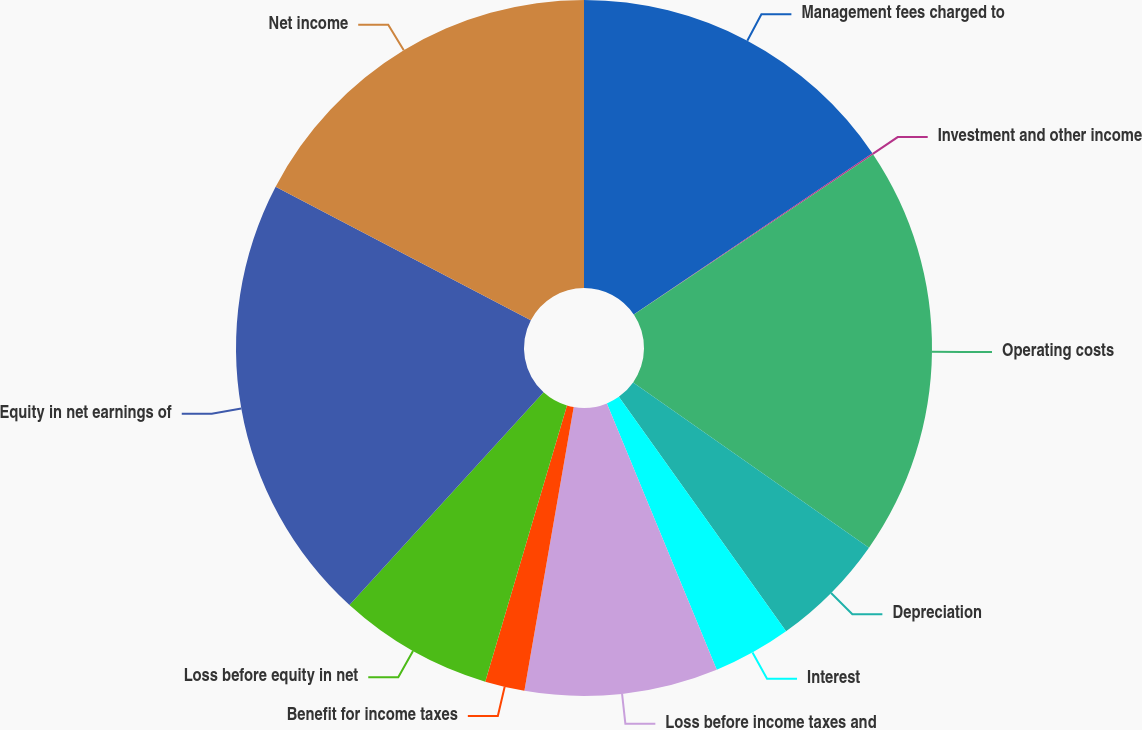<chart> <loc_0><loc_0><loc_500><loc_500><pie_chart><fcel>Management fees charged to<fcel>Investment and other income<fcel>Operating costs<fcel>Depreciation<fcel>Interest<fcel>Loss before income taxes and<fcel>Benefit for income taxes<fcel>Loss before equity in net<fcel>Equity in net earnings of<fcel>Net income<nl><fcel>15.55%<fcel>0.06%<fcel>19.12%<fcel>5.41%<fcel>3.63%<fcel>8.97%<fcel>1.84%<fcel>7.19%<fcel>20.9%<fcel>17.33%<nl></chart> 